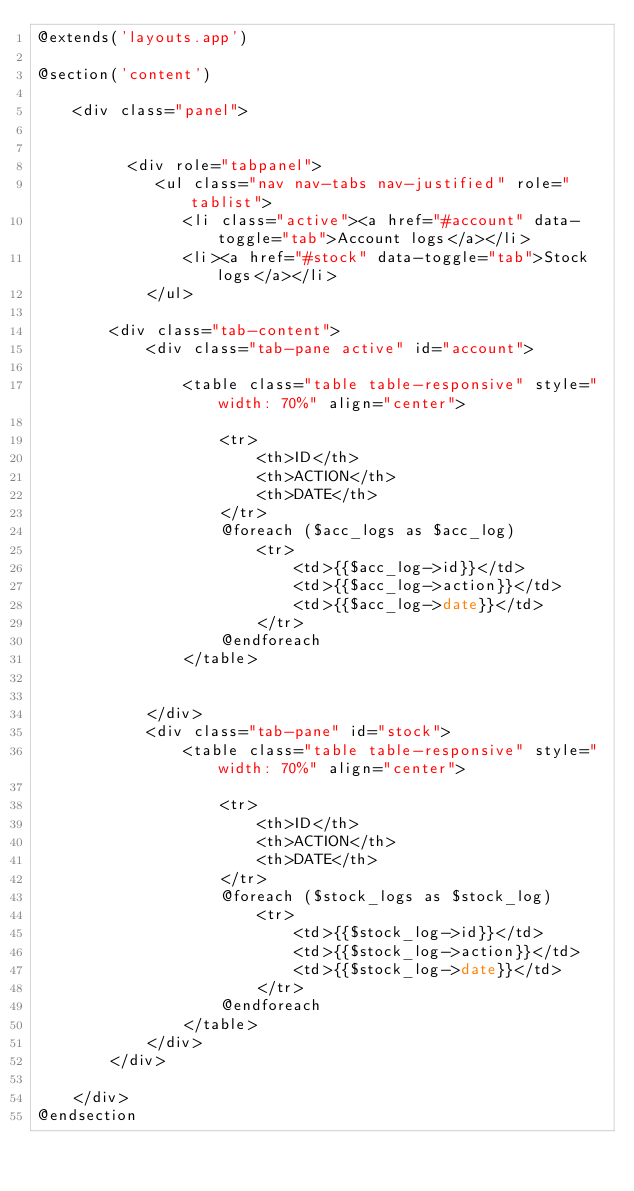<code> <loc_0><loc_0><loc_500><loc_500><_PHP_>@extends('layouts.app')

@section('content')
	
	<div class="panel">
		

		  <div role="tabpanel">
		 	 <ul class="nav nav-tabs nav-justified" role="tablist">
			    <li class="active"><a href="#account" data-toggle="tab">Account logs</a></li>
			    <li><a href="#stock" data-toggle="tab">Stock logs</a></li>   
			</ul>

		<div class="tab-content">
		    <div class="tab-pane active" id="account">

		    	<table class="table table-responsive" style="width: 70%" align="center">

					<tr>
						<th>ID</th>
						<th>ACTION</th>
						<th>DATE</th>
					</tr>
					@foreach ($acc_logs as $acc_log)
						<tr>
						    <td>{{$acc_log->id}}</td>
						    <td>{{$acc_log->action}}</td>
						    <td>{{$acc_log->date}}</td>
						</tr>
					@endforeach
				</table>	


		    </div>
		    <div class="tab-pane" id="stock">
		    	<table class="table table-responsive" style="width: 70%" align="center">

					<tr>
						<th>ID</th>
						<th>ACTION</th>
						<th>DATE</th>
					</tr>
					@foreach ($stock_logs as $stock_log)
						<tr>
						    <td>{{$stock_log->id}}</td>
						    <td>{{$stock_log->action}}</td>
						    <td>{{$stock_log->date}}</td>
						</tr>
					@endforeach
				</table>
		    </div>
		</div>

	</div>
@endsection
</code> 